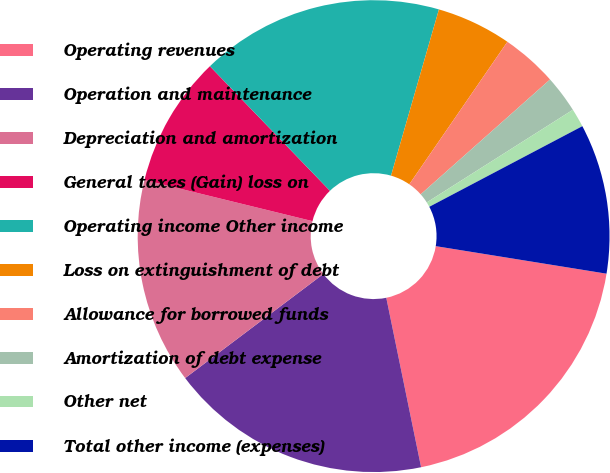<chart> <loc_0><loc_0><loc_500><loc_500><pie_chart><fcel>Operating revenues<fcel>Operation and maintenance<fcel>Depreciation and amortization<fcel>General taxes (Gain) loss on<fcel>Operating income Other income<fcel>Loss on extinguishment of debt<fcel>Allowance for borrowed funds<fcel>Amortization of debt expense<fcel>Other net<fcel>Total other income (expenses)<nl><fcel>19.23%<fcel>17.95%<fcel>14.1%<fcel>8.97%<fcel>16.67%<fcel>5.13%<fcel>3.85%<fcel>2.56%<fcel>1.28%<fcel>10.26%<nl></chart> 